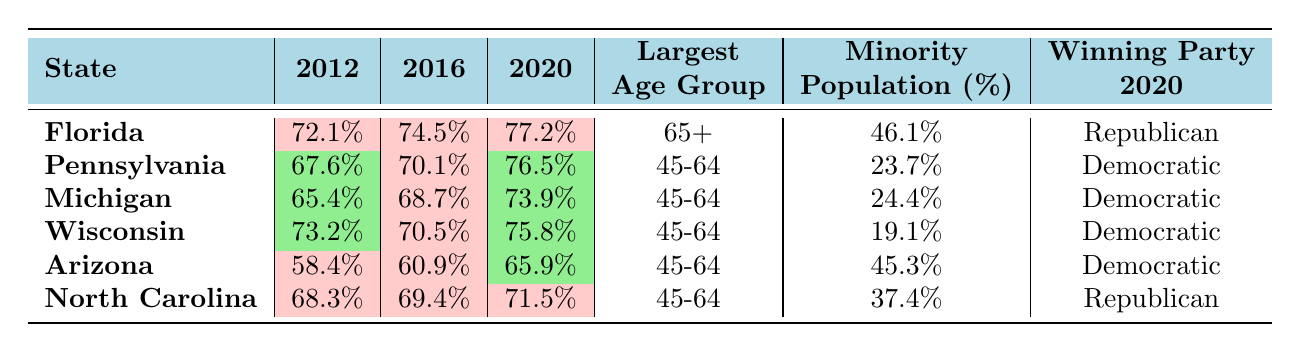What was the voter turnout in Florida for the 2020 election? The table indicates that the voter turnout in Florida for the 2020 election is listed as 77.2%.
Answer: 77.2% Which state had the highest voter turnout in 2016? By examining the 2016 column for each state, Florida had the highest voter turnout at 74.5%.
Answer: Florida What is the average voter turnout for Wisconsin over the three elections? Adding Wisconsin's voter turnout percentages: (73.2 + 70.5 + 75.8) = 219.5. Dividing by 3 gives an average of 219.5/3 = 73.17.
Answer: 73.17 Did Arizona have a higher voter turnout in 2020 compared to 2012? Looking at the two years, Arizona had a voter turnout of 65.9% in 2020 and 58.4% in 2012. Since 65.9% is greater than 58.4%, the answer is yes.
Answer: Yes Which state's largest age group is 65 and older? The table shows that Florida has the largest age group of 65+ among all listed states.
Answer: Florida What is the percentage of the minority population in Michigan? Referring to the key demographics section of the table, Michigan's minority population percentage is 24.4%.
Answer: 24.4% Which state switched winning parties from the 2016 election to the 2020 election? After reviewing the winning party data, Arizona switched its winning party from Republican in both 2012 and 2016 to Democratic in 2020.
Answer: Arizona Calculate the difference in voter turnout between Pennsylvania in 2012 and 2020. For Pennsylvania, the voter turnout was 67.6% in 2012 and 76.5% in 2020. The difference is 76.5% - 67.6% = 8.9%.
Answer: 8.9% In which state did the percentage of the minority population exceed 40%? Checking the minority population percentages, both Florida and Arizona have percentages over 40% (46.1% and 45.3%, respectively).
Answer: Florida and Arizona 